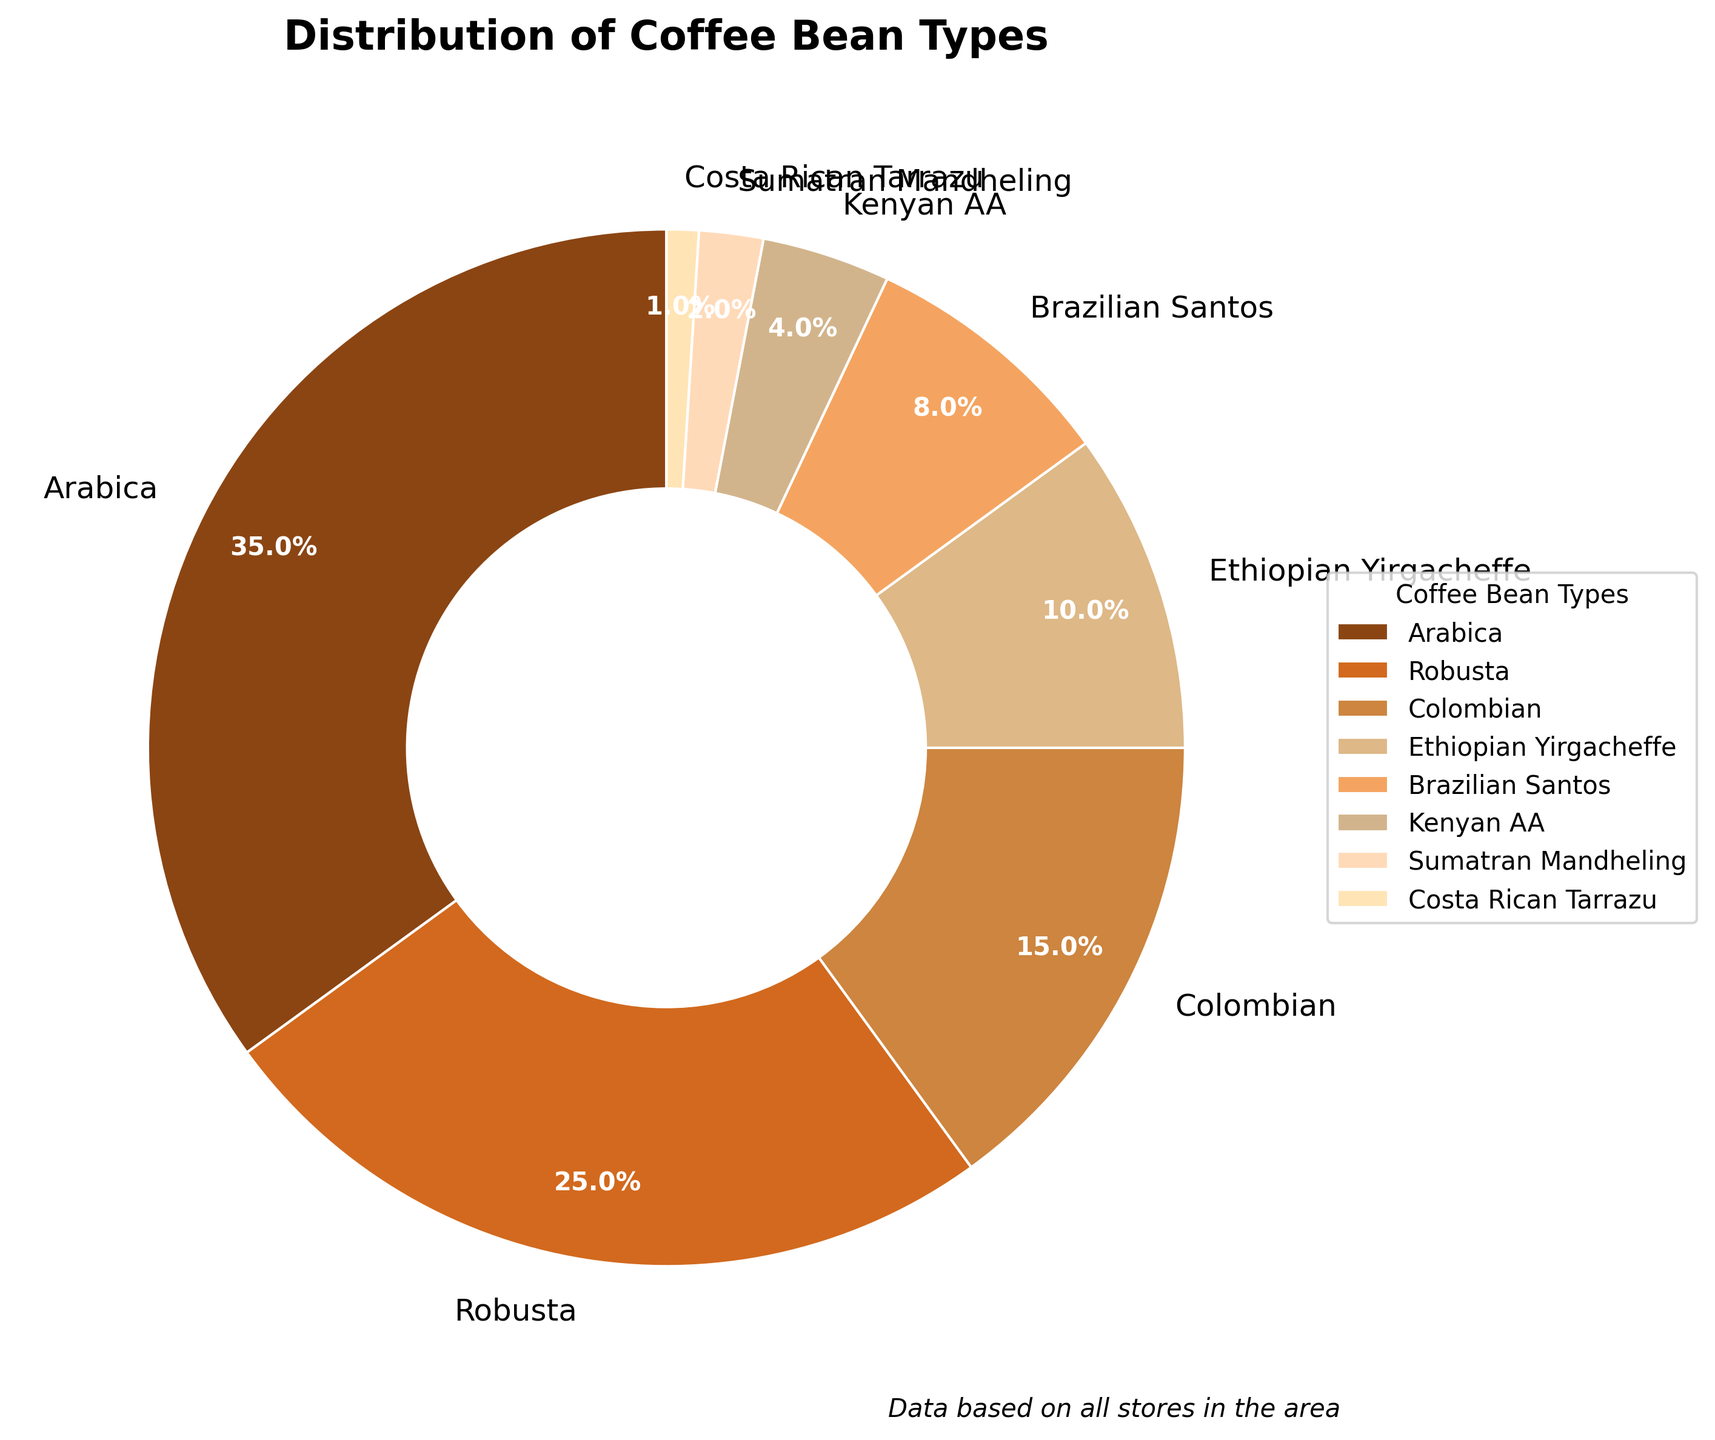What's the most common type of coffee bean used? The pie chart shows that Arabica comprises the largest segment at 35%. By identifying the largest segment, we determine that the most common type of coffee bean used is Arabica.
Answer: Arabica What percentage of the coffee beans are from Colombian and Brazilian Santos combined? According to the pie chart, Colombian beans account for 15%, and Brazilian Santos account for 8%. Summing these percentages, 15% + 8%, we get 23%.
Answer: 23% Is Robusta more popular than Ethiopian Yirgacheffe? By comparing the sizes of the segments, Robusta has 25%, whereas Ethiopian Yirgacheffe has 10%. Since 25% is greater than 10%, Robusta is more popular.
Answer: Yes Which bean type has the smallest share in the distribution? Observing the pie chart, Costa Rican Tarrazu has the smallest segment at 1%.
Answer: Costa Rican Tarrazu How many bean types contribute less than 10% to the total distribution? The pie chart shows that Ethiopian Yirgacheffe, Brazilian Santos, Kenyan AA, Sumatran Mandheling, and Costa Rican Tarrazu each contribute less than 10%. Counting these, we find there are five types.
Answer: 5 What visual attributes are used to differentiate between the different types of beans? The pie chart uses different colors for each type of coffee bean and labels them accordingly. The slices are also proportionate to their percentage share.
Answer: Colors and labels Which bean type is twice as common as Colombian? The pie chart indicates that Arabica is 35%, which is more than double the Colombian's 15%.
Answer: Arabica If we combined the percentages of Kenyan AA and Sumatran Mandheling, would it surpass Ethiopian Yirgacheffe? Kenyan AA holds 4%, and Sumatran Mandheling holds 2%. Combined, 4% + 2% = 6%, which is less than Ethiopian Yirgacheffe's 10%.
Answer: No Which two types of beans have a combined share closest to 25%? Brazilian Santos (8%) and Colombian (15%) together add up to 23%, which is closest to 25%.
Answer: Brazilian Santos and Colombian Identify the bean type with a share closest to the average share of all bean types. The total average is obtained by dividing 100% by 8 types, resulting in 12.5%. The type closest to this average is Ethiopian Yirgacheffe with 10%.
Answer: Ethiopian Yirgacheffe 